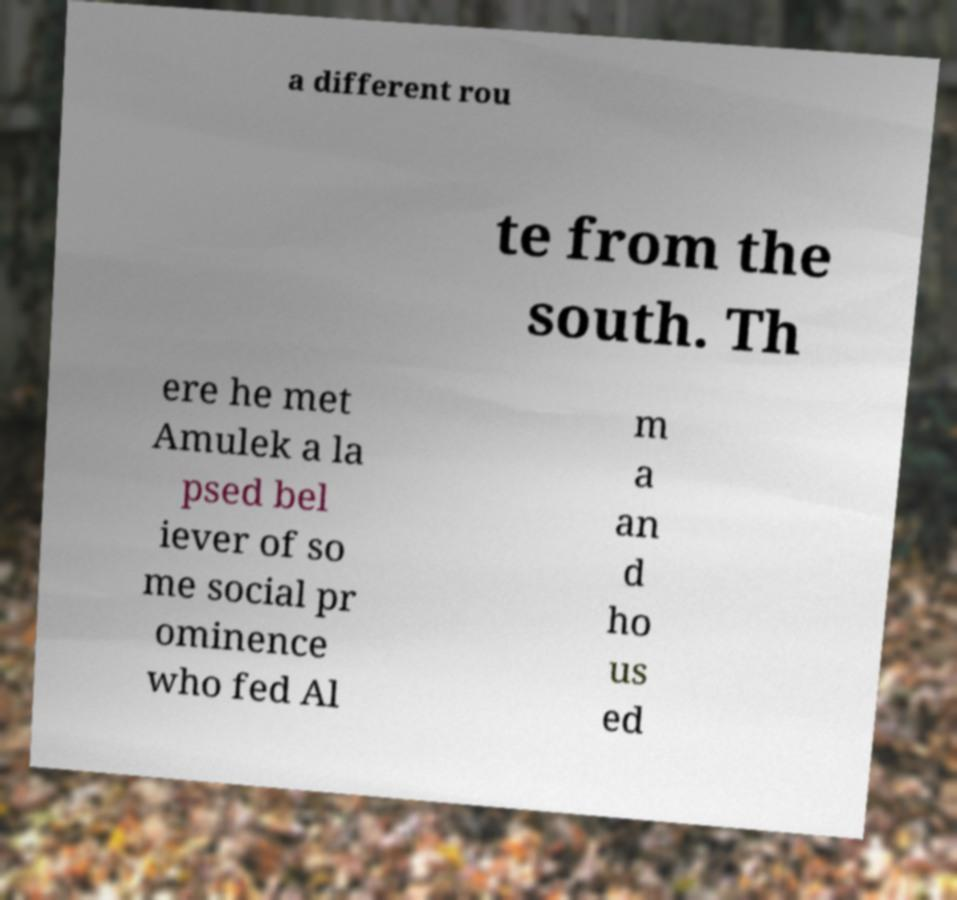Please read and relay the text visible in this image. What does it say? a different rou te from the south. Th ere he met Amulek a la psed bel iever of so me social pr ominence who fed Al m a an d ho us ed 